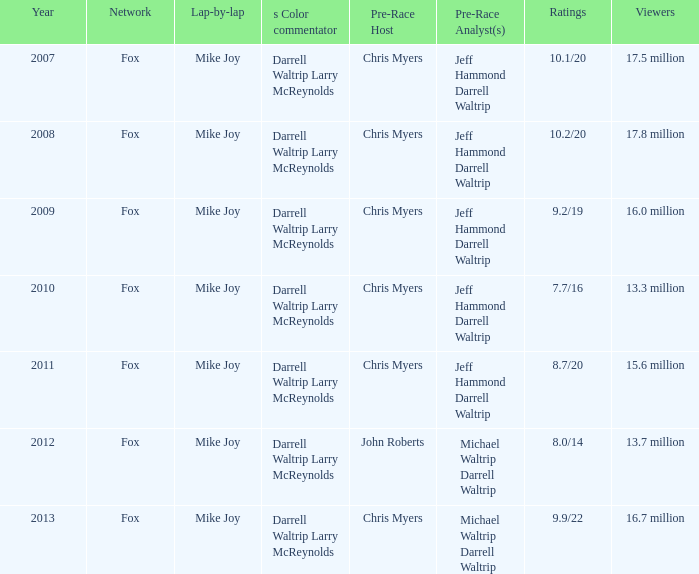Can you give me this table as a dict? {'header': ['Year', 'Network', 'Lap-by-lap', 's Color commentator', 'Pre-Race Host', 'Pre-Race Analyst(s)', 'Ratings', 'Viewers'], 'rows': [['2007', 'Fox', 'Mike Joy', 'Darrell Waltrip Larry McReynolds', 'Chris Myers', 'Jeff Hammond Darrell Waltrip', '10.1/20', '17.5 million'], ['2008', 'Fox', 'Mike Joy', 'Darrell Waltrip Larry McReynolds', 'Chris Myers', 'Jeff Hammond Darrell Waltrip', '10.2/20', '17.8 million'], ['2009', 'Fox', 'Mike Joy', 'Darrell Waltrip Larry McReynolds', 'Chris Myers', 'Jeff Hammond Darrell Waltrip', '9.2/19', '16.0 million'], ['2010', 'Fox', 'Mike Joy', 'Darrell Waltrip Larry McReynolds', 'Chris Myers', 'Jeff Hammond Darrell Waltrip', '7.7/16', '13.3 million'], ['2011', 'Fox', 'Mike Joy', 'Darrell Waltrip Larry McReynolds', 'Chris Myers', 'Jeff Hammond Darrell Waltrip', '8.7/20', '15.6 million'], ['2012', 'Fox', 'Mike Joy', 'Darrell Waltrip Larry McReynolds', 'John Roberts', 'Michael Waltrip Darrell Waltrip', '8.0/14', '13.7 million'], ['2013', 'Fox', 'Mike Joy', 'Darrell Waltrip Larry McReynolds', 'Chris Myers', 'Michael Waltrip Darrell Waltrip', '9.9/22', '16.7 million']]} Which network has an audience of 1 Fox. 